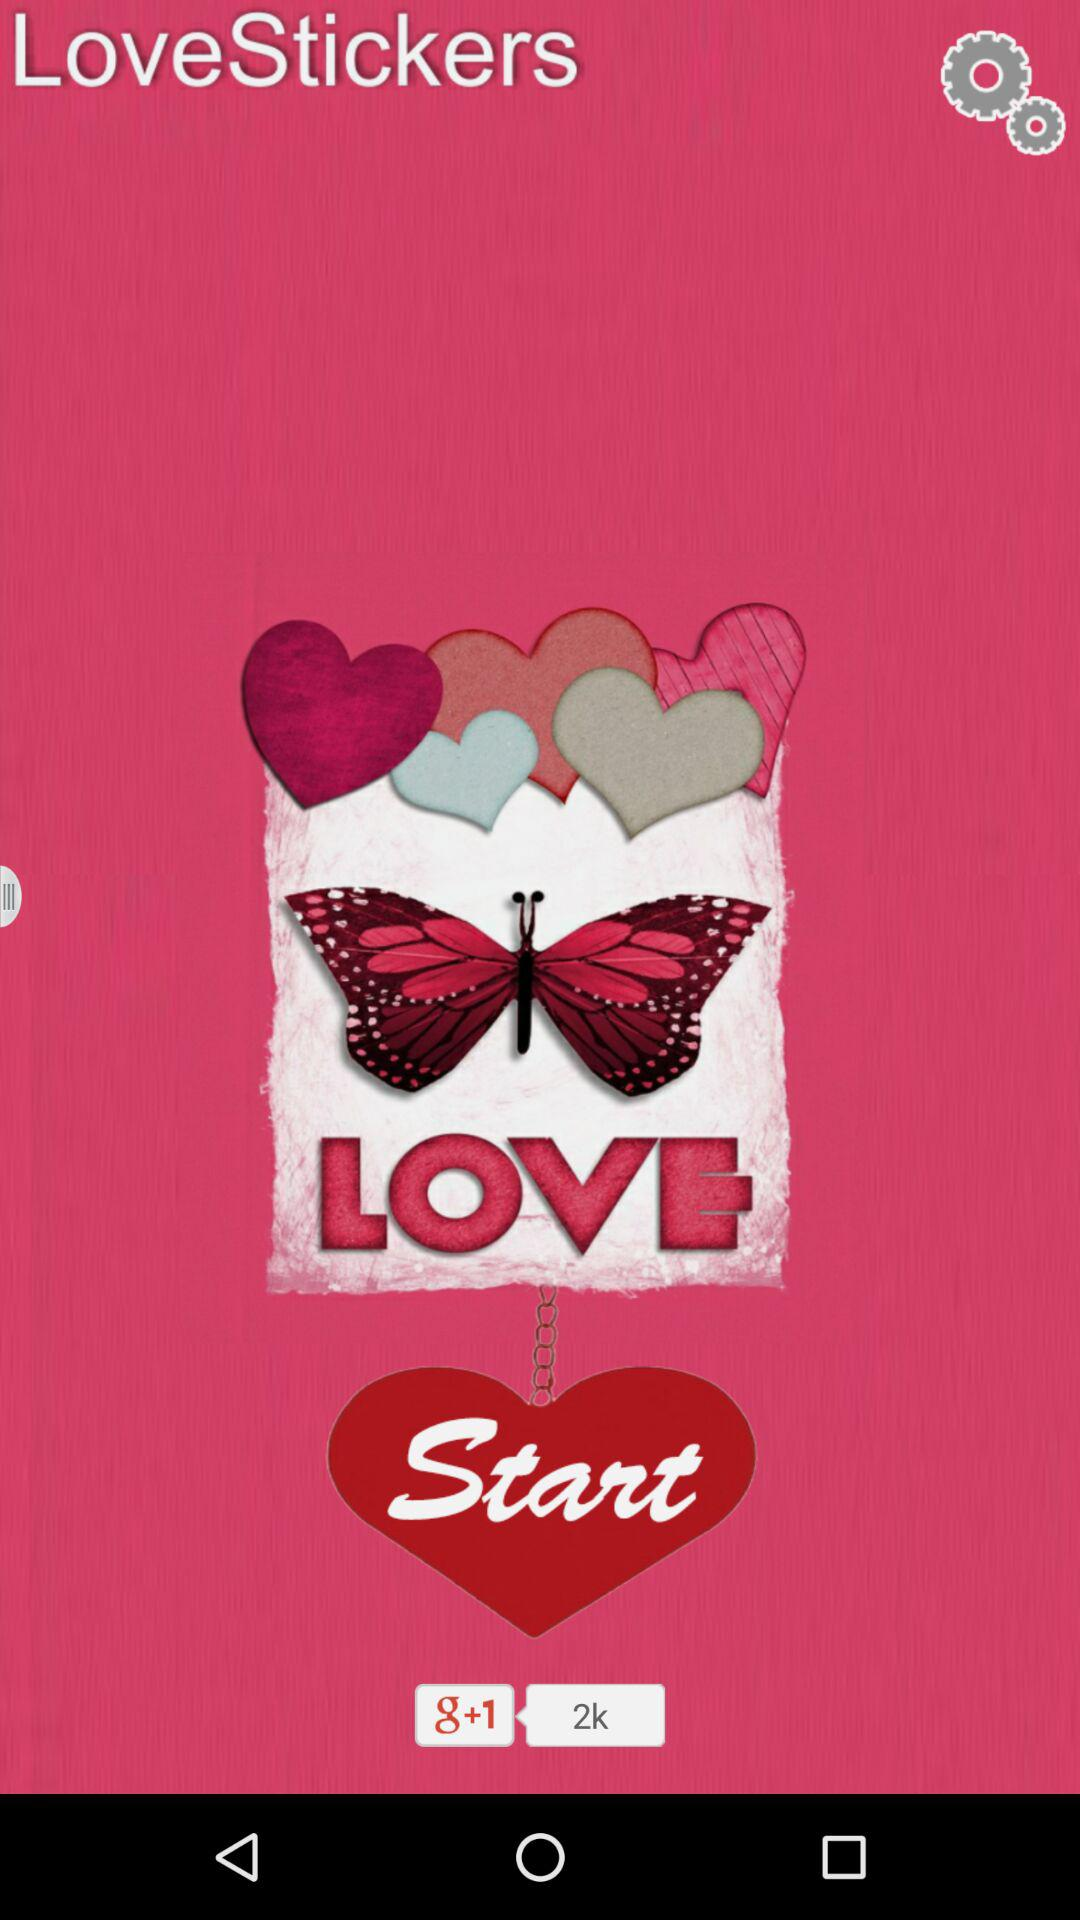How many stickers are there in the bottom row?
Answer the question using a single word or phrase. 2 